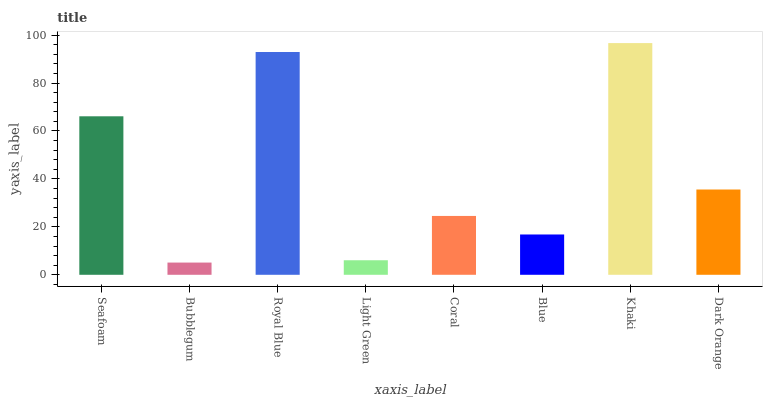Is Bubblegum the minimum?
Answer yes or no. Yes. Is Khaki the maximum?
Answer yes or no. Yes. Is Royal Blue the minimum?
Answer yes or no. No. Is Royal Blue the maximum?
Answer yes or no. No. Is Royal Blue greater than Bubblegum?
Answer yes or no. Yes. Is Bubblegum less than Royal Blue?
Answer yes or no. Yes. Is Bubblegum greater than Royal Blue?
Answer yes or no. No. Is Royal Blue less than Bubblegum?
Answer yes or no. No. Is Dark Orange the high median?
Answer yes or no. Yes. Is Coral the low median?
Answer yes or no. Yes. Is Light Green the high median?
Answer yes or no. No. Is Bubblegum the low median?
Answer yes or no. No. 